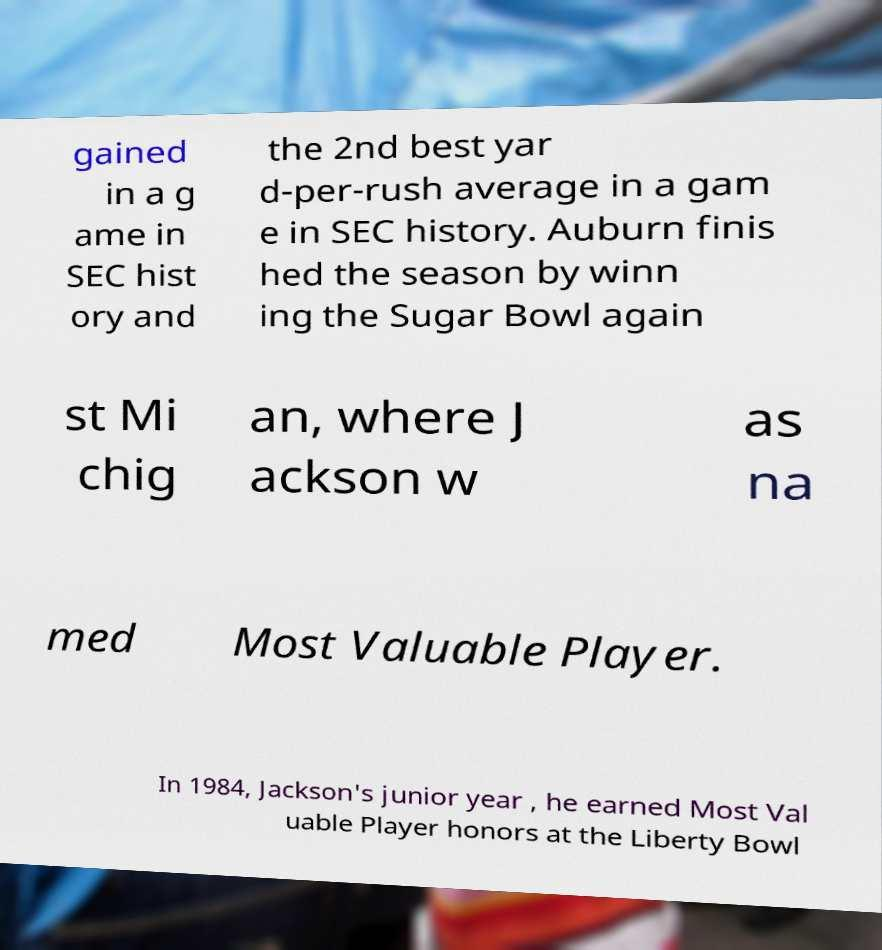For documentation purposes, I need the text within this image transcribed. Could you provide that? gained in a g ame in SEC hist ory and the 2nd best yar d-per-rush average in a gam e in SEC history. Auburn finis hed the season by winn ing the Sugar Bowl again st Mi chig an, where J ackson w as na med Most Valuable Player. In 1984, Jackson's junior year , he earned Most Val uable Player honors at the Liberty Bowl 